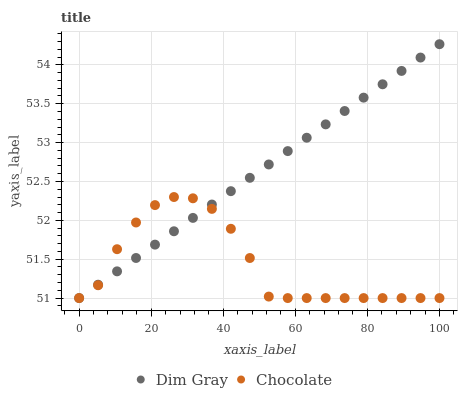Does Chocolate have the minimum area under the curve?
Answer yes or no. Yes. Does Dim Gray have the maximum area under the curve?
Answer yes or no. Yes. Does Chocolate have the maximum area under the curve?
Answer yes or no. No. Is Dim Gray the smoothest?
Answer yes or no. Yes. Is Chocolate the roughest?
Answer yes or no. Yes. Is Chocolate the smoothest?
Answer yes or no. No. Does Dim Gray have the lowest value?
Answer yes or no. Yes. Does Dim Gray have the highest value?
Answer yes or no. Yes. Does Chocolate have the highest value?
Answer yes or no. No. Does Chocolate intersect Dim Gray?
Answer yes or no. Yes. Is Chocolate less than Dim Gray?
Answer yes or no. No. Is Chocolate greater than Dim Gray?
Answer yes or no. No. 